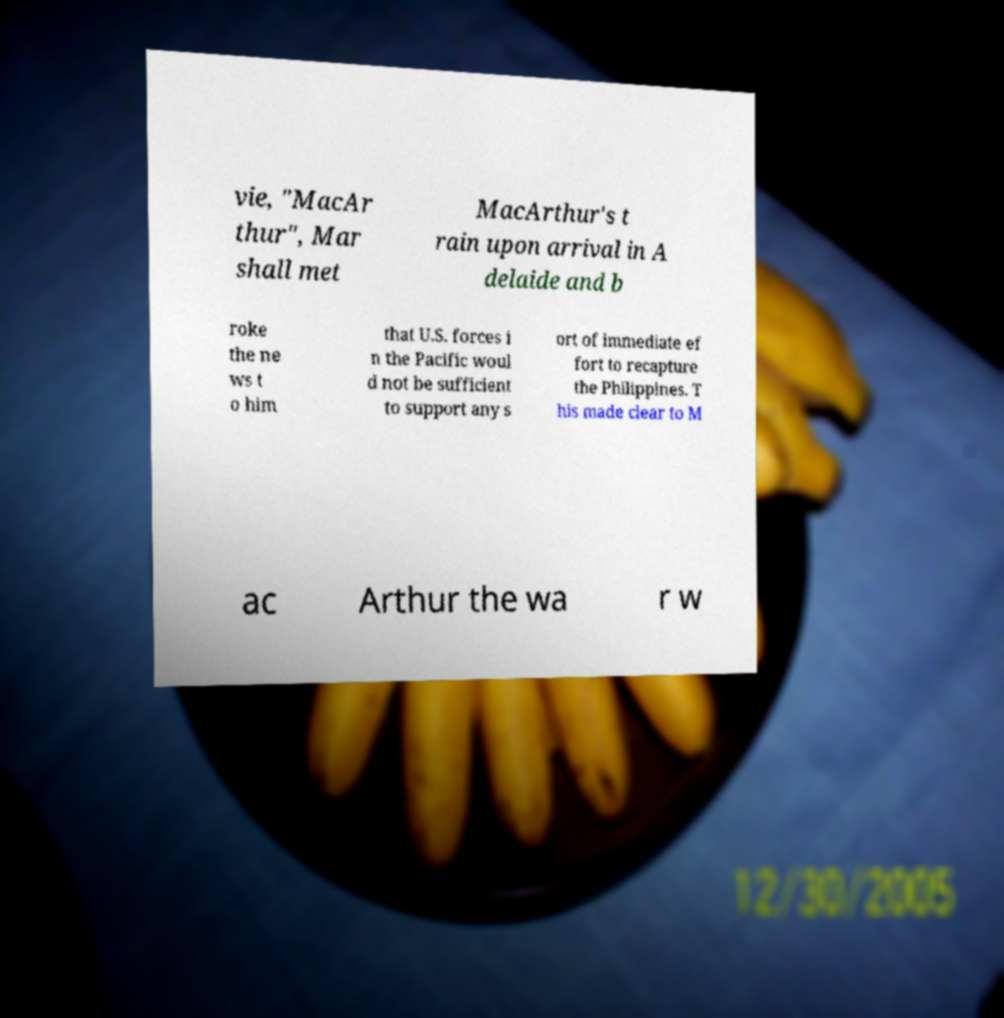Could you extract and type out the text from this image? vie, "MacAr thur", Mar shall met MacArthur's t rain upon arrival in A delaide and b roke the ne ws t o him that U.S. forces i n the Pacific woul d not be sufficient to support any s ort of immediate ef fort to recapture the Philippines. T his made clear to M ac Arthur the wa r w 